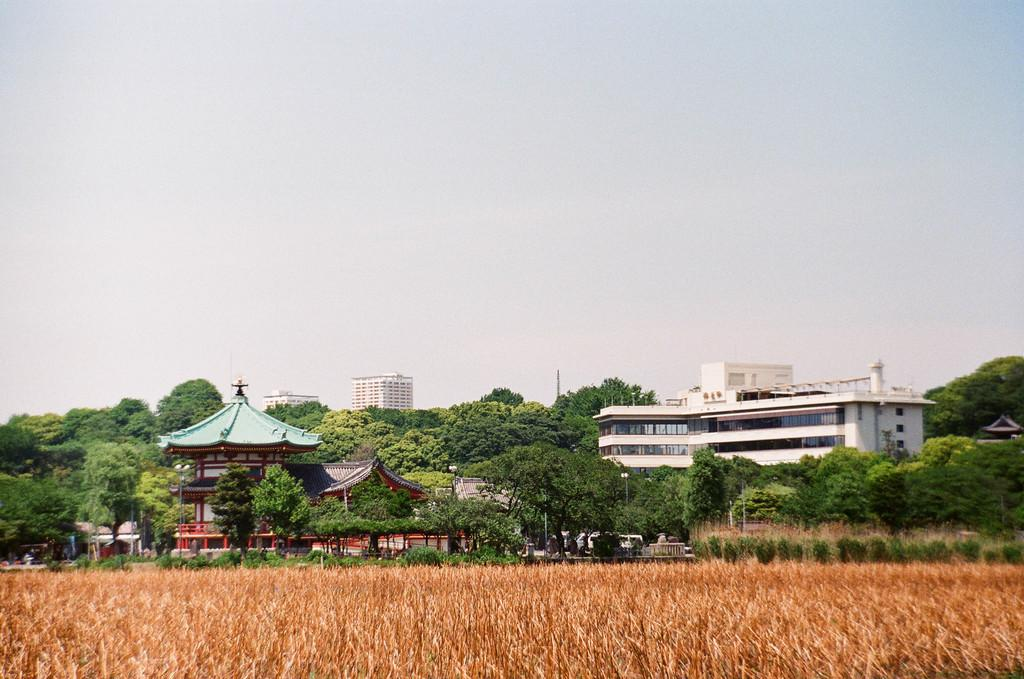What is the setting of the image? The image is an outside view. What can be seen at the bottom of the image? There is a field at the bottom of the image. What is located in the middle of the image? There are many buildings and trees in the middle of the image. What is visible at the top of the image? The sky is visible at the top of the image. How does the grass in the field rub against the trees in the image? There is no interaction between the grass and trees depicted in the image; they are separate elements in the scene. 